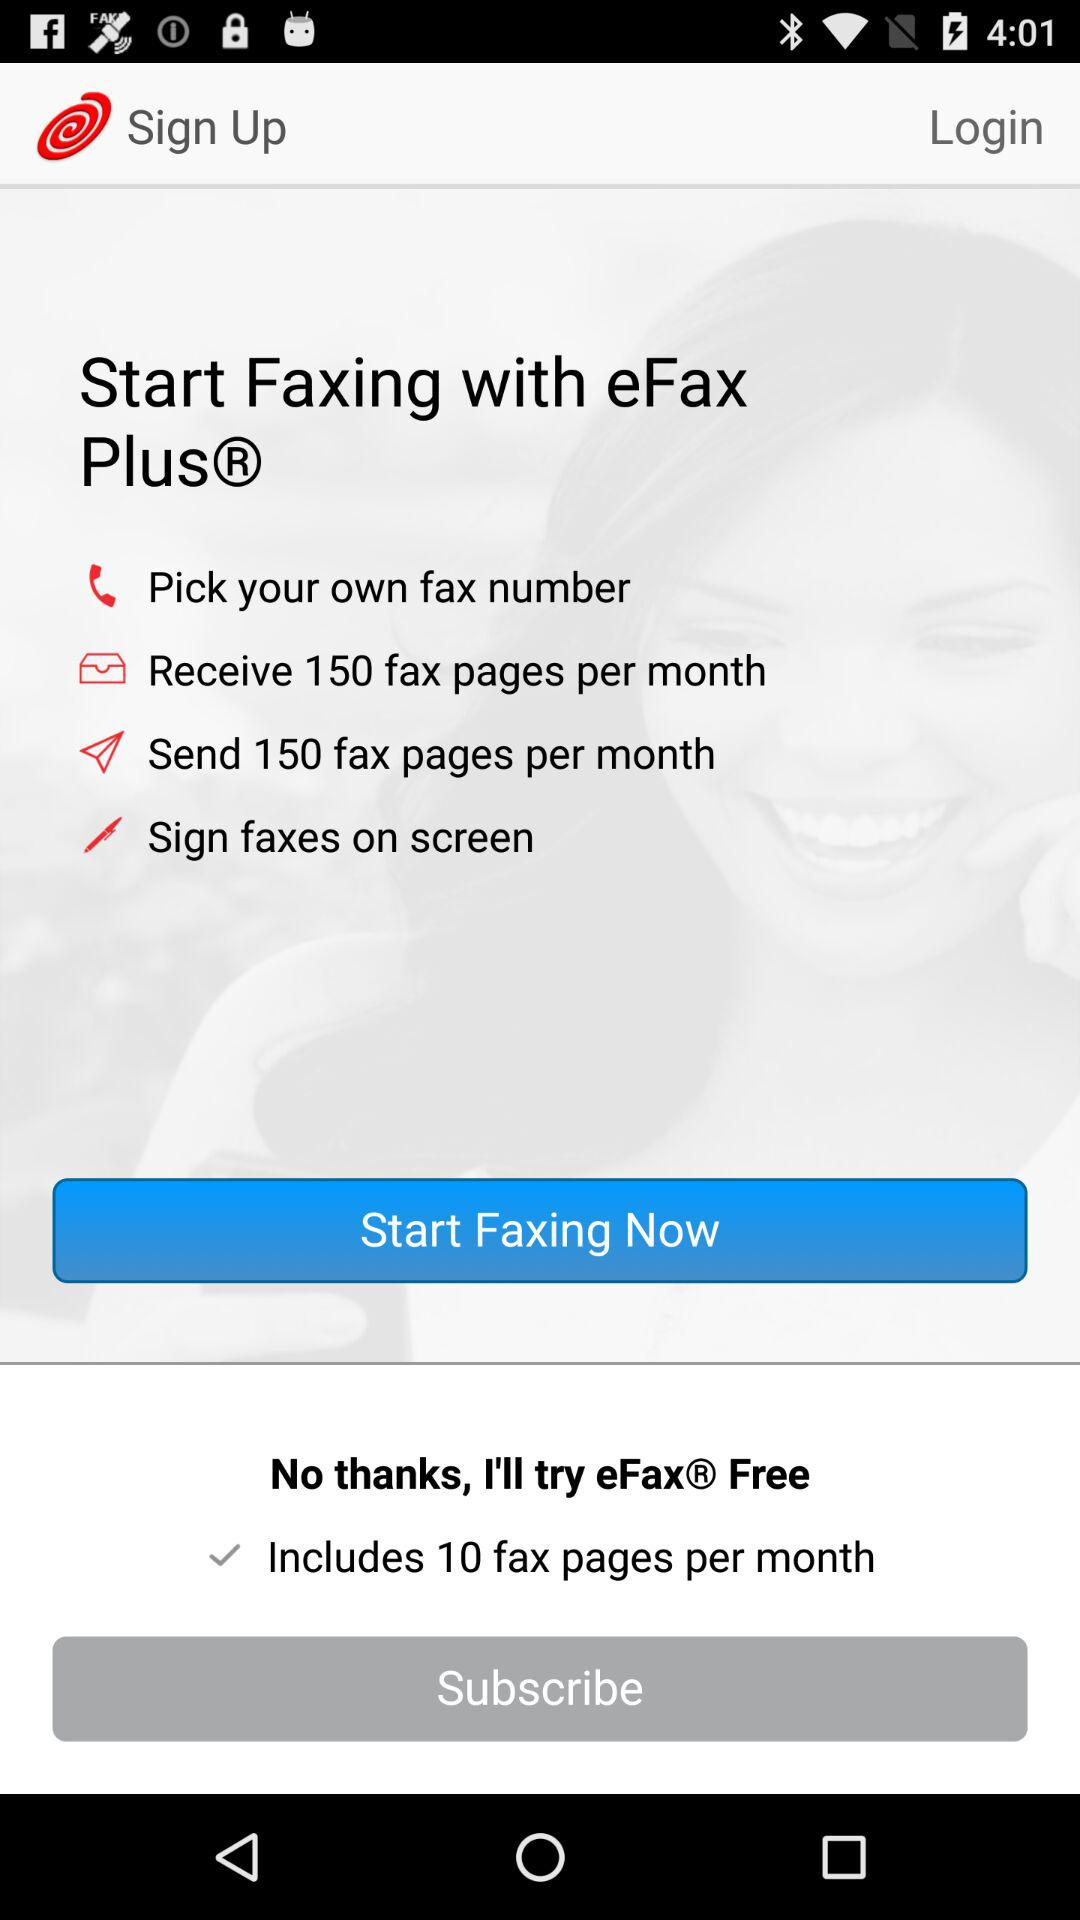How many fax pages can we send per month? You can send 150 fax pages per month. 